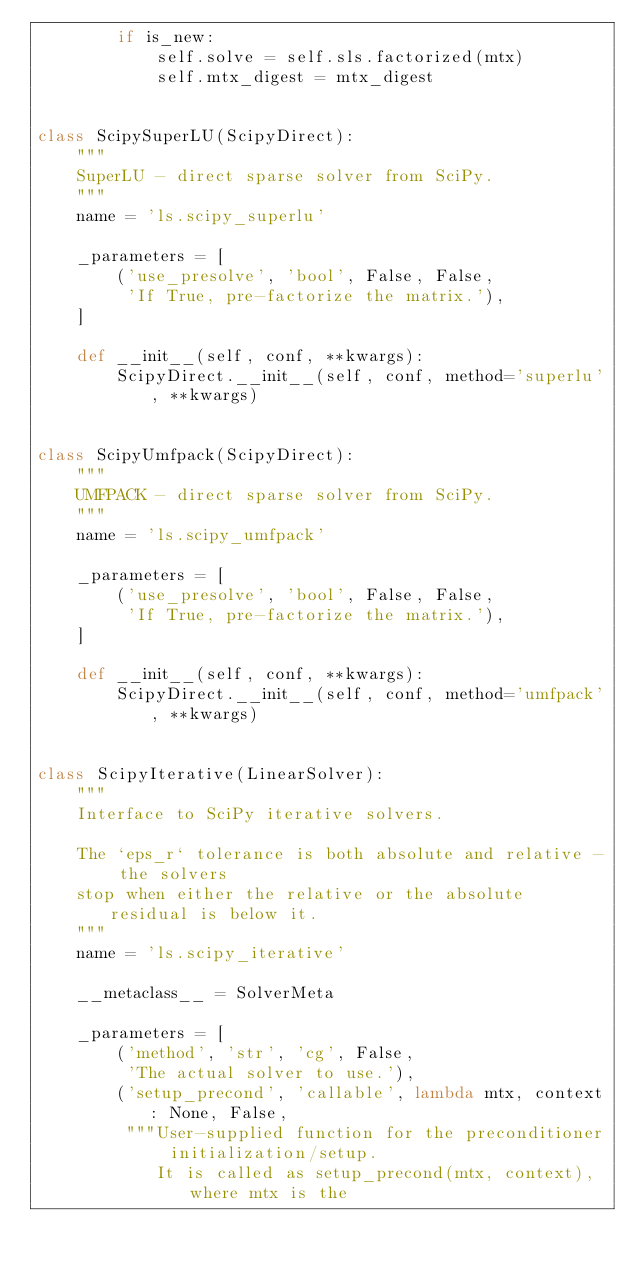<code> <loc_0><loc_0><loc_500><loc_500><_Python_>        if is_new:
            self.solve = self.sls.factorized(mtx)
            self.mtx_digest = mtx_digest


class ScipySuperLU(ScipyDirect):
    """
    SuperLU - direct sparse solver from SciPy.
    """
    name = 'ls.scipy_superlu'

    _parameters = [
        ('use_presolve', 'bool', False, False,
         'If True, pre-factorize the matrix.'),
    ]

    def __init__(self, conf, **kwargs):
        ScipyDirect.__init__(self, conf, method='superlu', **kwargs)


class ScipyUmfpack(ScipyDirect):
    """
    UMFPACK - direct sparse solver from SciPy.
    """
    name = 'ls.scipy_umfpack'

    _parameters = [
        ('use_presolve', 'bool', False, False,
         'If True, pre-factorize the matrix.'),
    ]

    def __init__(self, conf, **kwargs):
        ScipyDirect.__init__(self, conf, method='umfpack', **kwargs)


class ScipyIterative(LinearSolver):
    """
    Interface to SciPy iterative solvers.

    The `eps_r` tolerance is both absolute and relative - the solvers
    stop when either the relative or the absolute residual is below it.
    """
    name = 'ls.scipy_iterative'

    __metaclass__ = SolverMeta

    _parameters = [
        ('method', 'str', 'cg', False,
         'The actual solver to use.'),
        ('setup_precond', 'callable', lambda mtx, context: None, False,
         """User-supplied function for the preconditioner initialization/setup.
            It is called as setup_precond(mtx, context), where mtx is the</code> 